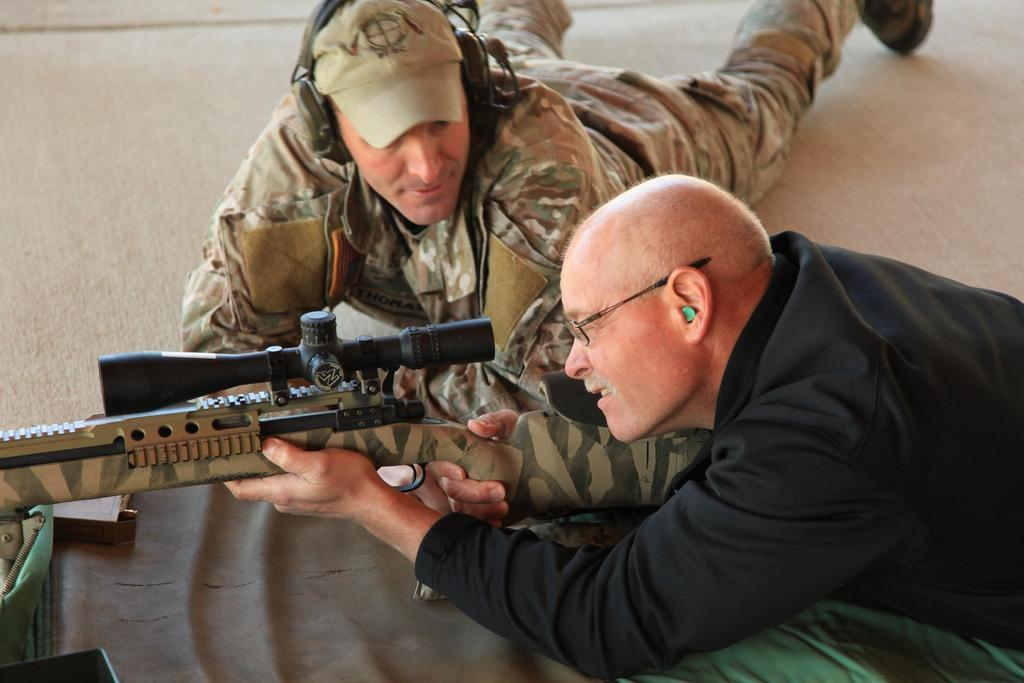How many people are in the image? There are two men in the image. What are the positions of the men in the image? Both men are lying down. What is the first man holding in the image? The first man is holding a gun. What is the second man doing in the image? The second man is watching the first man. What type of eggs can be seen in the image? There are no eggs present in the image. How does the first man stop the second man from hearing the gunshot? The image does not depict a gunshot or any action to prevent the second man from hearing it. 